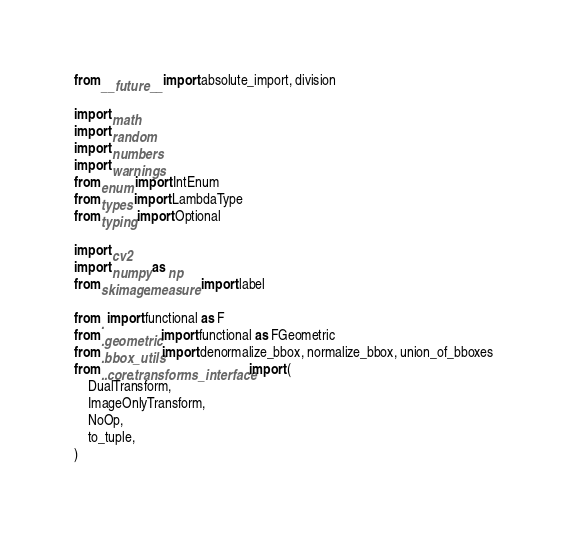<code> <loc_0><loc_0><loc_500><loc_500><_Python_>from __future__ import absolute_import, division

import math
import random
import numbers
import warnings
from enum import IntEnum
from types import LambdaType
from typing import Optional

import cv2
import numpy as np
from skimage.measure import label

from . import functional as F
from .geometric import functional as FGeometric
from .bbox_utils import denormalize_bbox, normalize_bbox, union_of_bboxes
from ..core.transforms_interface import (
    DualTransform,
    ImageOnlyTransform,
    NoOp,
    to_tuple,
)</code> 